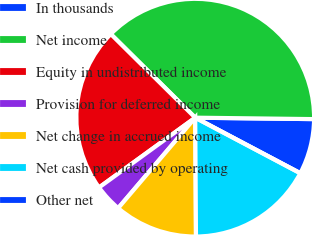Convert chart. <chart><loc_0><loc_0><loc_500><loc_500><pie_chart><fcel>In thousands<fcel>Net income<fcel>Equity in undistributed income<fcel>Provision for deferred income<fcel>Net change in accrued income<fcel>Net cash provided by operating<fcel>Other net<nl><fcel>7.55%<fcel>37.77%<fcel>22.41%<fcel>3.78%<fcel>11.33%<fcel>17.16%<fcel>0.0%<nl></chart> 